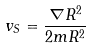<formula> <loc_0><loc_0><loc_500><loc_500>v _ { S } = \frac { \nabla R ^ { 2 } } { 2 m R ^ { 2 } }</formula> 